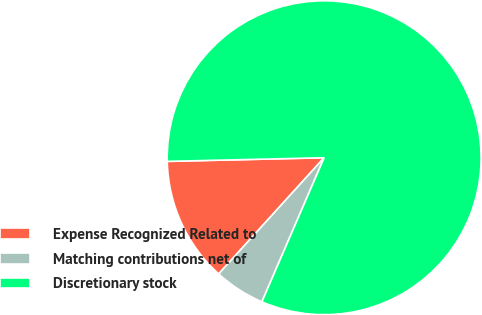Convert chart. <chart><loc_0><loc_0><loc_500><loc_500><pie_chart><fcel>Expense Recognized Related to<fcel>Matching contributions net of<fcel>Discretionary stock<nl><fcel>12.9%<fcel>5.24%<fcel>81.86%<nl></chart> 